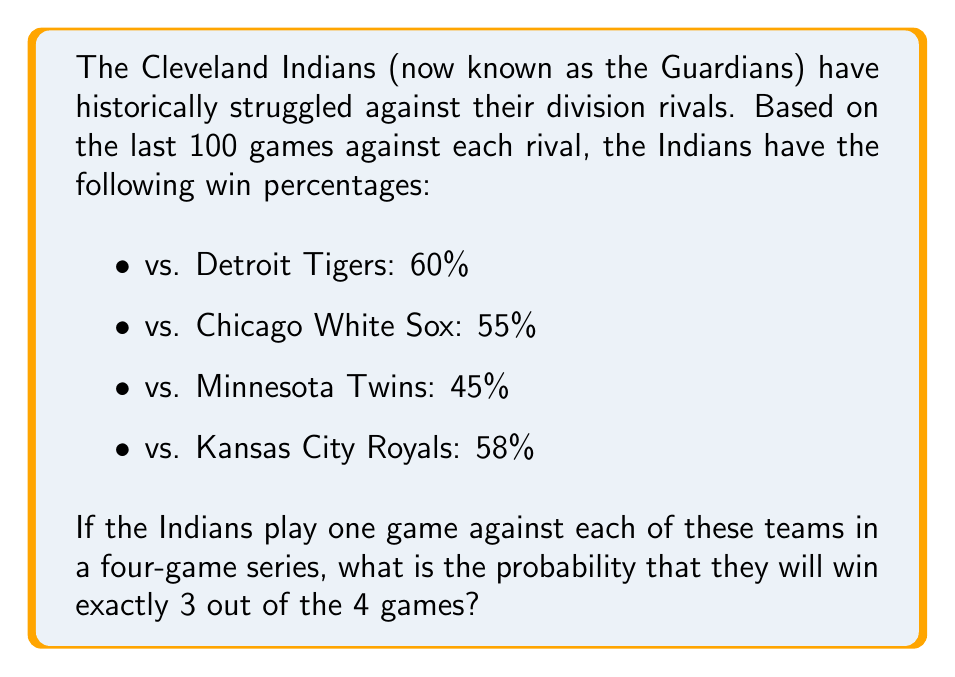Show me your answer to this math problem. To solve this problem, we'll use the concept of probability for independent events and the binomial probability formula.

1. First, let's convert the win percentages to probabilities:
   $p_{Tigers} = 0.60$
   $p_{WhiteSox} = 0.55$
   $p_{Twins} = 0.45$
   $p_{Royals} = 0.58$

2. We need to find the probability of winning exactly 3 out of 4 games. This can happen in 4 different ways:
   - Win against all teams except Tigers
   - Win against all teams except White Sox
   - Win against all teams except Twins
   - Win against all teams except Royals

3. Let's calculate the probability for each scenario:

   $P(\text{LWWW}) = (1-0.60) \times 0.55 \times 0.45 \times 0.58 = 0.0567$
   $P(\text{WLWW}) = 0.60 \times (1-0.55) \times 0.45 \times 0.58 = 0.0702$
   $P(\text{WWLW}) = 0.60 \times 0.55 \times (1-0.45) \times 0.58 = 0.1056$
   $P(\text{WWWL}) = 0.60 \times 0.55 \times 0.45 \times (1-0.58) = 0.0662$

4. The total probability is the sum of these individual probabilities:

   $P(\text{3 wins}) = 0.0567 + 0.0702 + 0.1056 + 0.0662 = 0.2987$

Therefore, the probability of the Indians winning exactly 3 out of 4 games against their division rivals is approximately 0.2987 or 29.87%.
Answer: $P(\text{3 wins}) = 0.2987$ or $29.87\%$ 